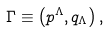Convert formula to latex. <formula><loc_0><loc_0><loc_500><loc_500>\Gamma \equiv \left ( p ^ { \Lambda } , q _ { \Lambda } \right ) ,</formula> 